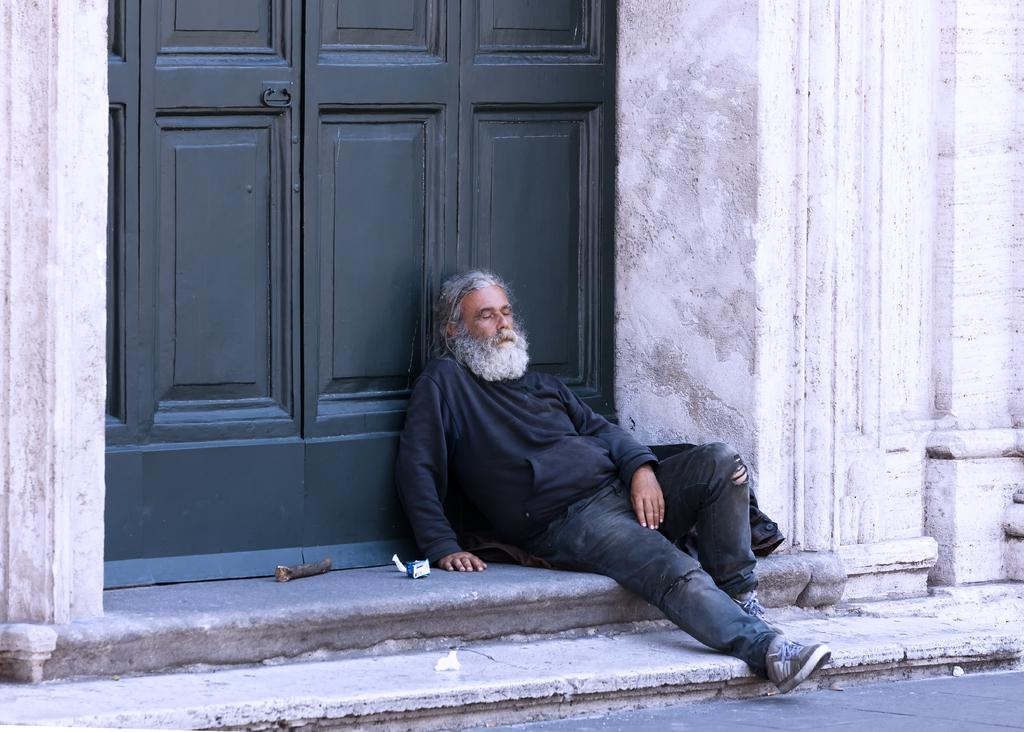What is the man in the image doing? The man is sitting in the image. What can be seen in the background of the image? There is a wall and a door visible in the background of the image. What page of the book is the man reading in the image? There is no book present in the image, so it is not possible to determine which page the man might be reading. 